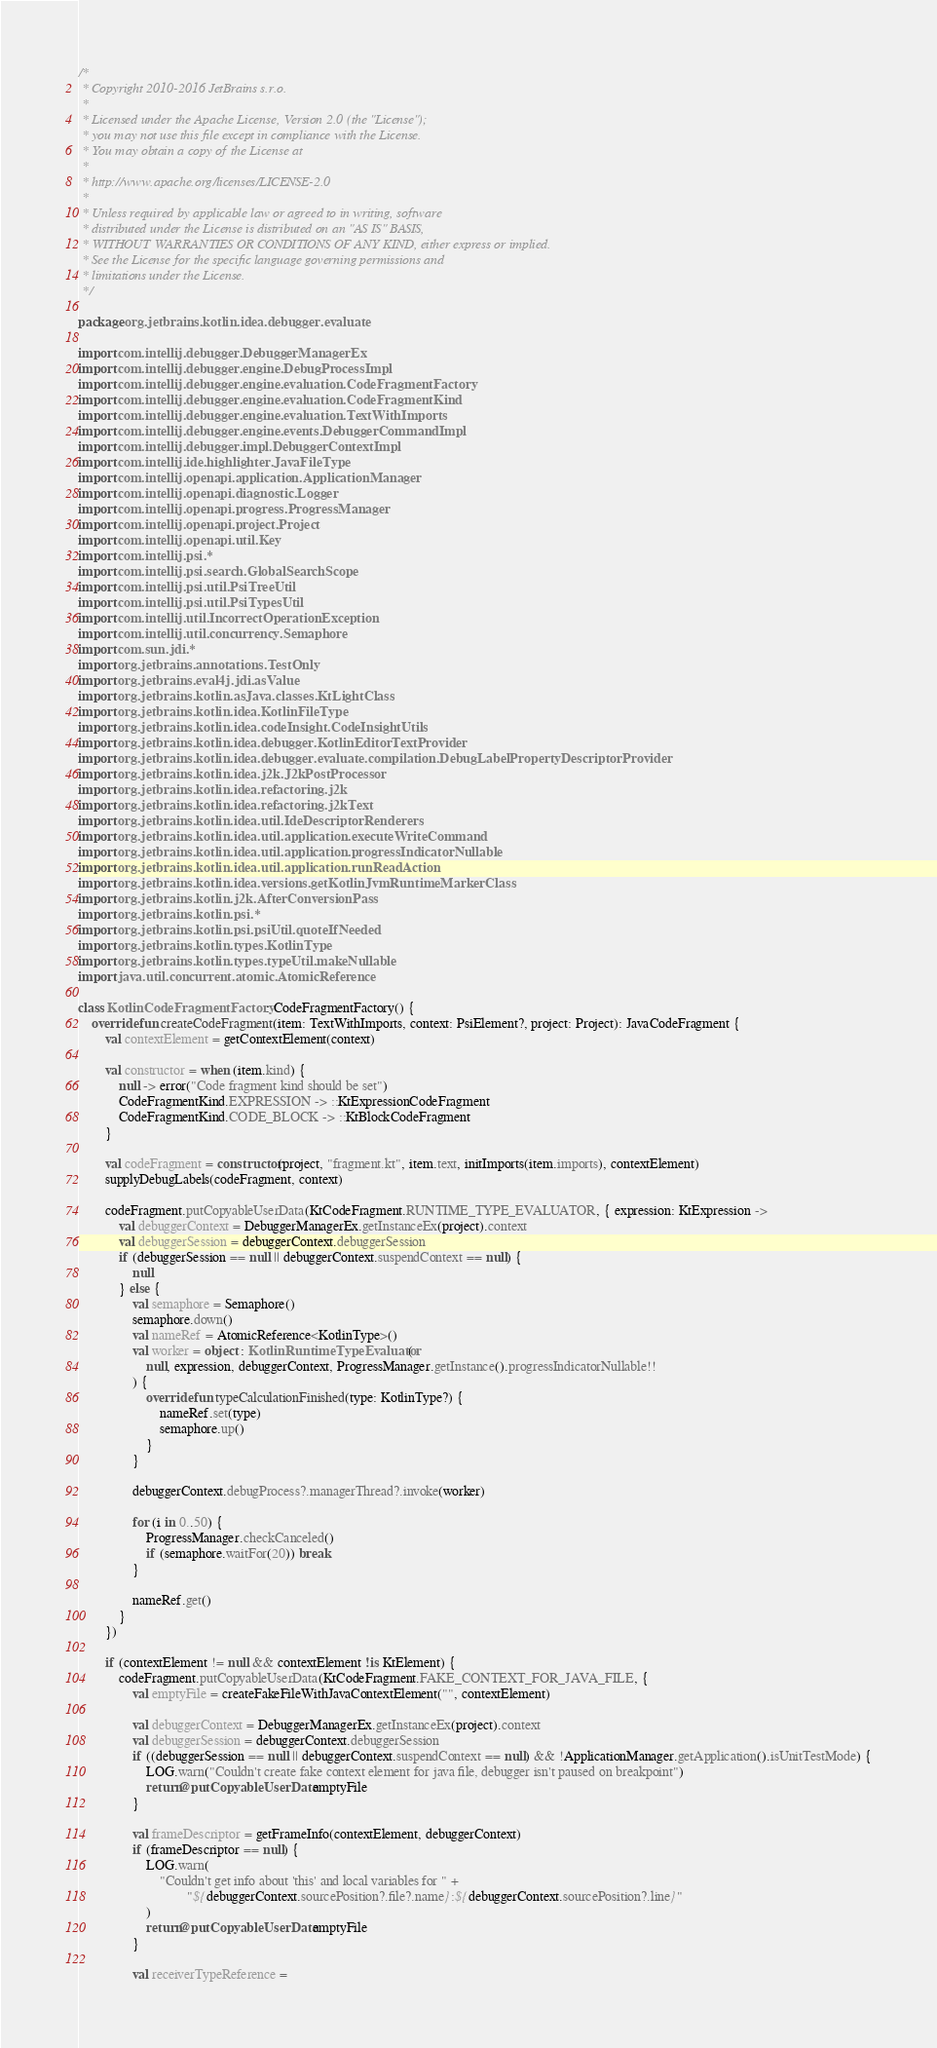<code> <loc_0><loc_0><loc_500><loc_500><_Kotlin_>/*
 * Copyright 2010-2016 JetBrains s.r.o.
 *
 * Licensed under the Apache License, Version 2.0 (the "License");
 * you may not use this file except in compliance with the License.
 * You may obtain a copy of the License at
 *
 * http://www.apache.org/licenses/LICENSE-2.0
 *
 * Unless required by applicable law or agreed to in writing, software
 * distributed under the License is distributed on an "AS IS" BASIS,
 * WITHOUT WARRANTIES OR CONDITIONS OF ANY KIND, either express or implied.
 * See the License for the specific language governing permissions and
 * limitations under the License.
 */

package org.jetbrains.kotlin.idea.debugger.evaluate

import com.intellij.debugger.DebuggerManagerEx
import com.intellij.debugger.engine.DebugProcessImpl
import com.intellij.debugger.engine.evaluation.CodeFragmentFactory
import com.intellij.debugger.engine.evaluation.CodeFragmentKind
import com.intellij.debugger.engine.evaluation.TextWithImports
import com.intellij.debugger.engine.events.DebuggerCommandImpl
import com.intellij.debugger.impl.DebuggerContextImpl
import com.intellij.ide.highlighter.JavaFileType
import com.intellij.openapi.application.ApplicationManager
import com.intellij.openapi.diagnostic.Logger
import com.intellij.openapi.progress.ProgressManager
import com.intellij.openapi.project.Project
import com.intellij.openapi.util.Key
import com.intellij.psi.*
import com.intellij.psi.search.GlobalSearchScope
import com.intellij.psi.util.PsiTreeUtil
import com.intellij.psi.util.PsiTypesUtil
import com.intellij.util.IncorrectOperationException
import com.intellij.util.concurrency.Semaphore
import com.sun.jdi.*
import org.jetbrains.annotations.TestOnly
import org.jetbrains.eval4j.jdi.asValue
import org.jetbrains.kotlin.asJava.classes.KtLightClass
import org.jetbrains.kotlin.idea.KotlinFileType
import org.jetbrains.kotlin.idea.codeInsight.CodeInsightUtils
import org.jetbrains.kotlin.idea.debugger.KotlinEditorTextProvider
import org.jetbrains.kotlin.idea.debugger.evaluate.compilation.DebugLabelPropertyDescriptorProvider
import org.jetbrains.kotlin.idea.j2k.J2kPostProcessor
import org.jetbrains.kotlin.idea.refactoring.j2k
import org.jetbrains.kotlin.idea.refactoring.j2kText
import org.jetbrains.kotlin.idea.util.IdeDescriptorRenderers
import org.jetbrains.kotlin.idea.util.application.executeWriteCommand
import org.jetbrains.kotlin.idea.util.application.progressIndicatorNullable
import org.jetbrains.kotlin.idea.util.application.runReadAction
import org.jetbrains.kotlin.idea.versions.getKotlinJvmRuntimeMarkerClass
import org.jetbrains.kotlin.j2k.AfterConversionPass
import org.jetbrains.kotlin.psi.*
import org.jetbrains.kotlin.psi.psiUtil.quoteIfNeeded
import org.jetbrains.kotlin.types.KotlinType
import org.jetbrains.kotlin.types.typeUtil.makeNullable
import java.util.concurrent.atomic.AtomicReference

class KotlinCodeFragmentFactory : CodeFragmentFactory() {
    override fun createCodeFragment(item: TextWithImports, context: PsiElement?, project: Project): JavaCodeFragment {
        val contextElement = getContextElement(context)

        val constructor = when (item.kind) {
            null -> error("Code fragment kind should be set")
            CodeFragmentKind.EXPRESSION -> ::KtExpressionCodeFragment
            CodeFragmentKind.CODE_BLOCK -> ::KtBlockCodeFragment
        }

        val codeFragment = constructor(project, "fragment.kt", item.text, initImports(item.imports), contextElement)
        supplyDebugLabels(codeFragment, context)

        codeFragment.putCopyableUserData(KtCodeFragment.RUNTIME_TYPE_EVALUATOR, { expression: KtExpression ->
            val debuggerContext = DebuggerManagerEx.getInstanceEx(project).context
            val debuggerSession = debuggerContext.debuggerSession
            if (debuggerSession == null || debuggerContext.suspendContext == null) {
                null
            } else {
                val semaphore = Semaphore()
                semaphore.down()
                val nameRef = AtomicReference<KotlinType>()
                val worker = object : KotlinRuntimeTypeEvaluator(
                    null, expression, debuggerContext, ProgressManager.getInstance().progressIndicatorNullable!!
                ) {
                    override fun typeCalculationFinished(type: KotlinType?) {
                        nameRef.set(type)
                        semaphore.up()
                    }
                }

                debuggerContext.debugProcess?.managerThread?.invoke(worker)

                for (i in 0..50) {
                    ProgressManager.checkCanceled()
                    if (semaphore.waitFor(20)) break
                }

                nameRef.get()
            }
        })

        if (contextElement != null && contextElement !is KtElement) {
            codeFragment.putCopyableUserData(KtCodeFragment.FAKE_CONTEXT_FOR_JAVA_FILE, {
                val emptyFile = createFakeFileWithJavaContextElement("", contextElement)

                val debuggerContext = DebuggerManagerEx.getInstanceEx(project).context
                val debuggerSession = debuggerContext.debuggerSession
                if ((debuggerSession == null || debuggerContext.suspendContext == null) && !ApplicationManager.getApplication().isUnitTestMode) {
                    LOG.warn("Couldn't create fake context element for java file, debugger isn't paused on breakpoint")
                    return@putCopyableUserData emptyFile
                }

                val frameDescriptor = getFrameInfo(contextElement, debuggerContext)
                if (frameDescriptor == null) {
                    LOG.warn(
                        "Couldn't get info about 'this' and local variables for " +
                                "${debuggerContext.sourcePosition?.file?.name}:${debuggerContext.sourcePosition?.line}"
                    )
                    return@putCopyableUserData emptyFile
                }

                val receiverTypeReference =</code> 